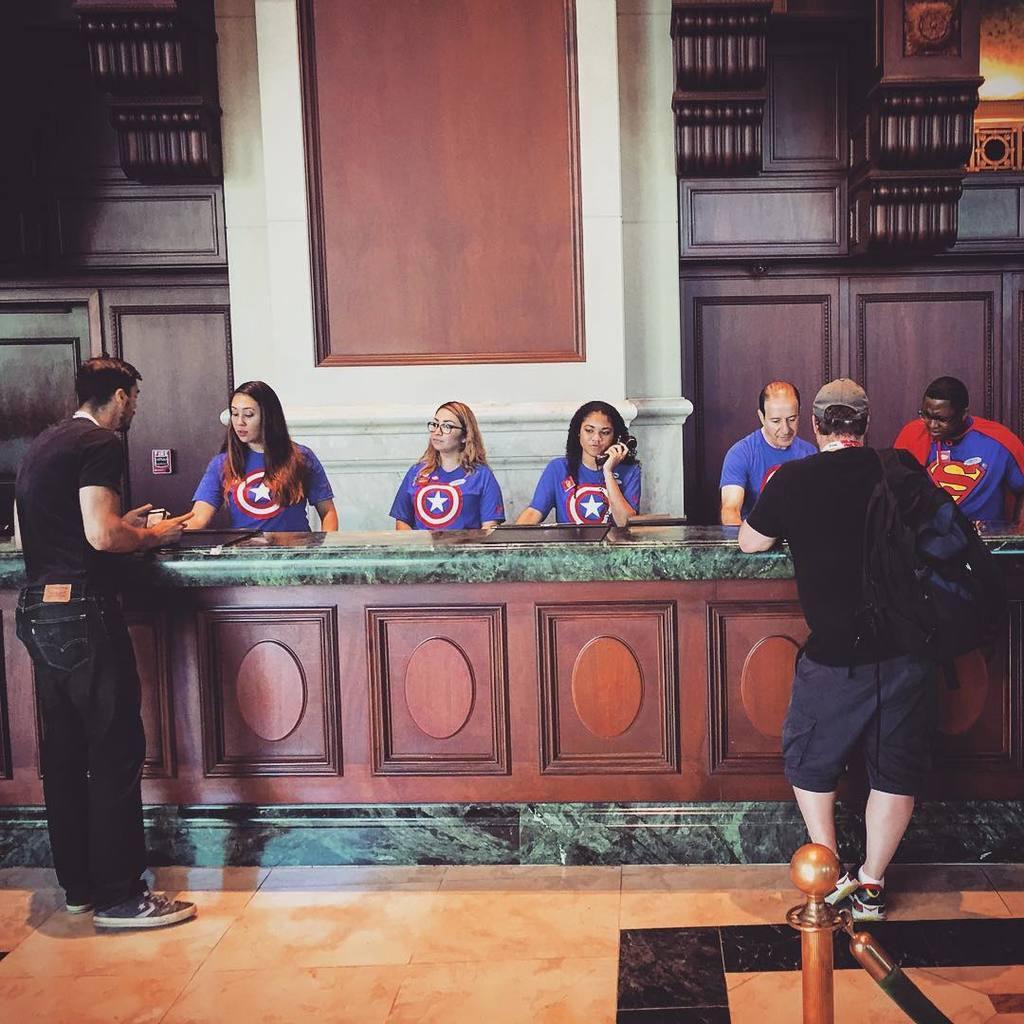How would you summarize this image in a sentence or two? In this picture I can see few people are standing and the picture shows an inner view of a building. 